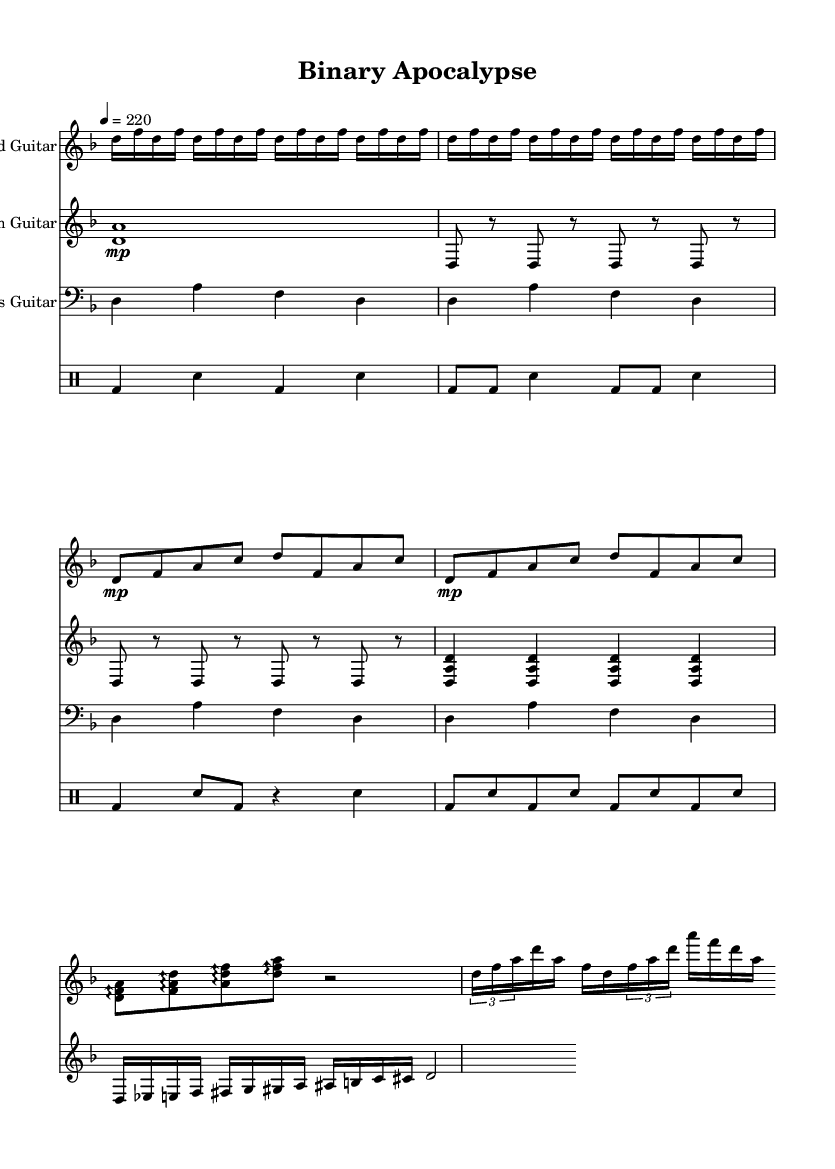What is the key signature of this music? The key signature is D minor, indicated by one flat (B flat) on the key signature line at the beginning of the staff.
Answer: D minor What is the time signature of this music? The time signature is 4/4, which is seen at the beginning of the music. This indicates that there are four beats in each measure and the quarter note receives one beat.
Answer: 4/4 What is the tempo marking? The tempo marking is 220 BPM, shown after the time signature, indicating a fast tempo.
Answer: 220 How many measures are in the intro of the lead guitar? The lead guitar’s intro consists of four measures, as indicated by the repeat markings and the corresponding note groupings.
Answer: 4 What type of musical structure is predominantly presented in the chorus? The chorus features arpeggios, evident from the arpeggio markings above the note groups that indicate a flow of harmony rather than melodic lines.
Answer: Arpeggios What kind of rhythmic complexity is presented in the drum section? The drum section exhibits syncopation, characterized by the alternating pattern of bass and snare notes that create an off-beat feel, which is common in metal music.
Answer: Syncopation How does the guitar solo differ from the regular sections in terms of complexity? The guitar solo introduces tuples, particularly the use of triplet figures, which adds to the intricacy compared to the straightforward rhythmic patterns of the Verse and Chorus.
Answer: Tuples 